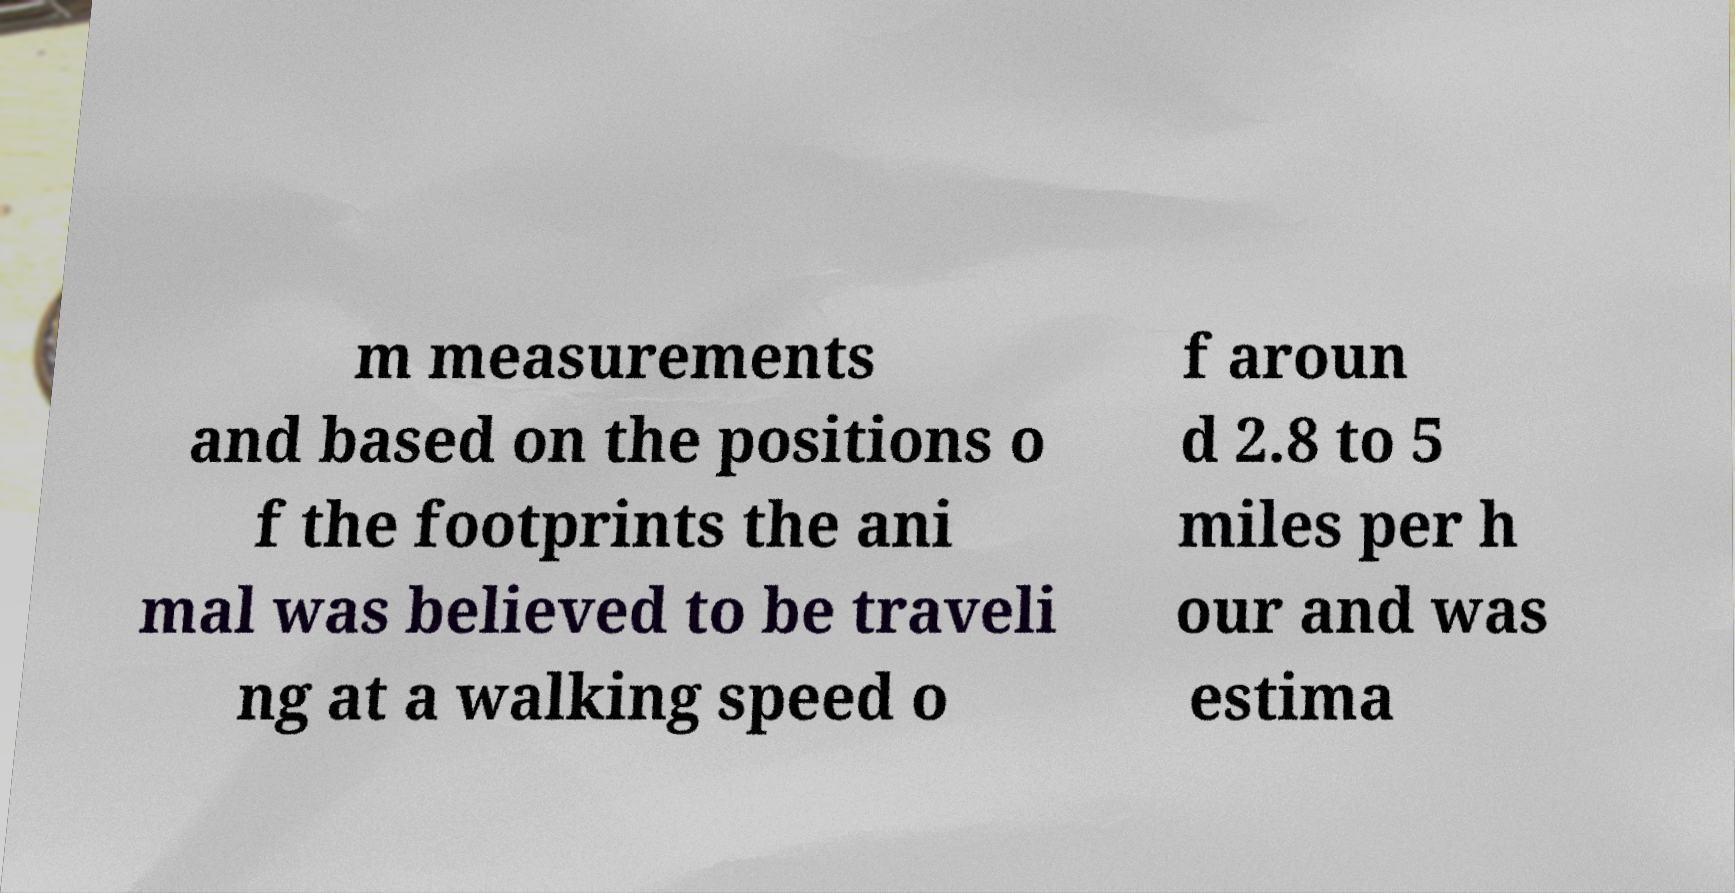Can you accurately transcribe the text from the provided image for me? m measurements and based on the positions o f the footprints the ani mal was believed to be traveli ng at a walking speed o f aroun d 2.8 to 5 miles per h our and was estima 